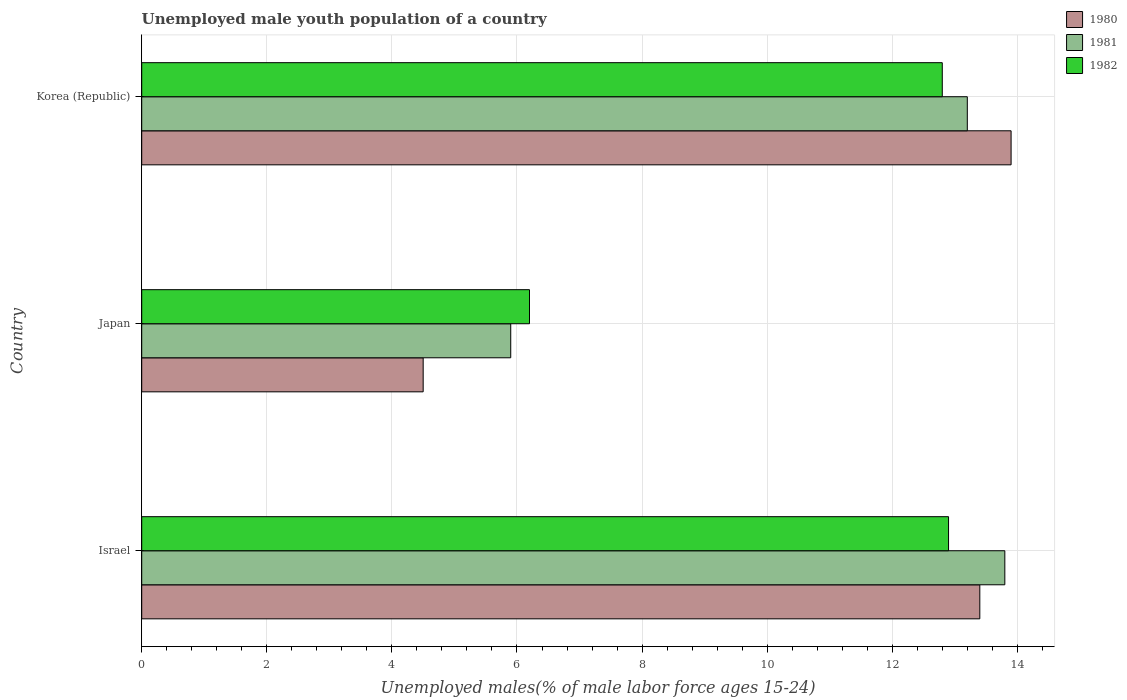Are the number of bars per tick equal to the number of legend labels?
Make the answer very short. Yes. How many bars are there on the 2nd tick from the top?
Your response must be concise. 3. How many bars are there on the 2nd tick from the bottom?
Provide a succinct answer. 3. What is the percentage of unemployed male youth population in 1982 in Japan?
Give a very brief answer. 6.2. Across all countries, what is the maximum percentage of unemployed male youth population in 1982?
Make the answer very short. 12.9. Across all countries, what is the minimum percentage of unemployed male youth population in 1982?
Give a very brief answer. 6.2. In which country was the percentage of unemployed male youth population in 1982 maximum?
Your answer should be very brief. Israel. What is the total percentage of unemployed male youth population in 1981 in the graph?
Your answer should be compact. 32.9. What is the difference between the percentage of unemployed male youth population in 1981 in Japan and that in Korea (Republic)?
Keep it short and to the point. -7.3. What is the difference between the percentage of unemployed male youth population in 1980 in Israel and the percentage of unemployed male youth population in 1982 in Japan?
Your response must be concise. 7.2. What is the average percentage of unemployed male youth population in 1981 per country?
Your response must be concise. 10.97. What is the difference between the percentage of unemployed male youth population in 1980 and percentage of unemployed male youth population in 1982 in Japan?
Keep it short and to the point. -1.7. What is the ratio of the percentage of unemployed male youth population in 1980 in Israel to that in Japan?
Give a very brief answer. 2.98. Is the difference between the percentage of unemployed male youth population in 1980 in Israel and Korea (Republic) greater than the difference between the percentage of unemployed male youth population in 1982 in Israel and Korea (Republic)?
Keep it short and to the point. No. What is the difference between the highest and the second highest percentage of unemployed male youth population in 1980?
Provide a short and direct response. 0.5. What is the difference between the highest and the lowest percentage of unemployed male youth population in 1980?
Offer a very short reply. 9.4. In how many countries, is the percentage of unemployed male youth population in 1982 greater than the average percentage of unemployed male youth population in 1982 taken over all countries?
Your response must be concise. 2. Is the sum of the percentage of unemployed male youth population in 1981 in Israel and Japan greater than the maximum percentage of unemployed male youth population in 1980 across all countries?
Provide a short and direct response. Yes. What does the 3rd bar from the bottom in Japan represents?
Provide a short and direct response. 1982. How many bars are there?
Offer a very short reply. 9. What is the difference between two consecutive major ticks on the X-axis?
Your response must be concise. 2. Are the values on the major ticks of X-axis written in scientific E-notation?
Offer a terse response. No. Does the graph contain any zero values?
Keep it short and to the point. No. How many legend labels are there?
Your answer should be very brief. 3. What is the title of the graph?
Ensure brevity in your answer.  Unemployed male youth population of a country. What is the label or title of the X-axis?
Your answer should be compact. Unemployed males(% of male labor force ages 15-24). What is the Unemployed males(% of male labor force ages 15-24) of 1980 in Israel?
Make the answer very short. 13.4. What is the Unemployed males(% of male labor force ages 15-24) of 1981 in Israel?
Give a very brief answer. 13.8. What is the Unemployed males(% of male labor force ages 15-24) in 1982 in Israel?
Your answer should be compact. 12.9. What is the Unemployed males(% of male labor force ages 15-24) of 1981 in Japan?
Provide a succinct answer. 5.9. What is the Unemployed males(% of male labor force ages 15-24) in 1982 in Japan?
Give a very brief answer. 6.2. What is the Unemployed males(% of male labor force ages 15-24) in 1980 in Korea (Republic)?
Your answer should be very brief. 13.9. What is the Unemployed males(% of male labor force ages 15-24) of 1981 in Korea (Republic)?
Give a very brief answer. 13.2. What is the Unemployed males(% of male labor force ages 15-24) in 1982 in Korea (Republic)?
Ensure brevity in your answer.  12.8. Across all countries, what is the maximum Unemployed males(% of male labor force ages 15-24) of 1980?
Give a very brief answer. 13.9. Across all countries, what is the maximum Unemployed males(% of male labor force ages 15-24) in 1981?
Your answer should be compact. 13.8. Across all countries, what is the maximum Unemployed males(% of male labor force ages 15-24) of 1982?
Provide a succinct answer. 12.9. Across all countries, what is the minimum Unemployed males(% of male labor force ages 15-24) in 1980?
Provide a succinct answer. 4.5. Across all countries, what is the minimum Unemployed males(% of male labor force ages 15-24) in 1981?
Provide a succinct answer. 5.9. Across all countries, what is the minimum Unemployed males(% of male labor force ages 15-24) in 1982?
Make the answer very short. 6.2. What is the total Unemployed males(% of male labor force ages 15-24) of 1980 in the graph?
Keep it short and to the point. 31.8. What is the total Unemployed males(% of male labor force ages 15-24) in 1981 in the graph?
Your answer should be compact. 32.9. What is the total Unemployed males(% of male labor force ages 15-24) of 1982 in the graph?
Provide a short and direct response. 31.9. What is the difference between the Unemployed males(% of male labor force ages 15-24) of 1980 in Israel and that in Japan?
Offer a very short reply. 8.9. What is the difference between the Unemployed males(% of male labor force ages 15-24) in 1981 in Japan and that in Korea (Republic)?
Ensure brevity in your answer.  -7.3. What is the difference between the Unemployed males(% of male labor force ages 15-24) of 1980 in Israel and the Unemployed males(% of male labor force ages 15-24) of 1982 in Japan?
Give a very brief answer. 7.2. What is the difference between the Unemployed males(% of male labor force ages 15-24) of 1981 in Israel and the Unemployed males(% of male labor force ages 15-24) of 1982 in Japan?
Keep it short and to the point. 7.6. What is the difference between the Unemployed males(% of male labor force ages 15-24) in 1980 in Japan and the Unemployed males(% of male labor force ages 15-24) in 1982 in Korea (Republic)?
Ensure brevity in your answer.  -8.3. What is the average Unemployed males(% of male labor force ages 15-24) in 1980 per country?
Ensure brevity in your answer.  10.6. What is the average Unemployed males(% of male labor force ages 15-24) of 1981 per country?
Offer a very short reply. 10.97. What is the average Unemployed males(% of male labor force ages 15-24) of 1982 per country?
Provide a succinct answer. 10.63. What is the difference between the Unemployed males(% of male labor force ages 15-24) of 1980 and Unemployed males(% of male labor force ages 15-24) of 1981 in Israel?
Make the answer very short. -0.4. What is the difference between the Unemployed males(% of male labor force ages 15-24) in 1981 and Unemployed males(% of male labor force ages 15-24) in 1982 in Israel?
Offer a terse response. 0.9. What is the difference between the Unemployed males(% of male labor force ages 15-24) in 1980 and Unemployed males(% of male labor force ages 15-24) in 1982 in Japan?
Give a very brief answer. -1.7. What is the difference between the Unemployed males(% of male labor force ages 15-24) of 1981 and Unemployed males(% of male labor force ages 15-24) of 1982 in Japan?
Your answer should be very brief. -0.3. What is the ratio of the Unemployed males(% of male labor force ages 15-24) of 1980 in Israel to that in Japan?
Provide a succinct answer. 2.98. What is the ratio of the Unemployed males(% of male labor force ages 15-24) in 1981 in Israel to that in Japan?
Provide a short and direct response. 2.34. What is the ratio of the Unemployed males(% of male labor force ages 15-24) of 1982 in Israel to that in Japan?
Provide a short and direct response. 2.08. What is the ratio of the Unemployed males(% of male labor force ages 15-24) of 1980 in Israel to that in Korea (Republic)?
Offer a terse response. 0.96. What is the ratio of the Unemployed males(% of male labor force ages 15-24) of 1981 in Israel to that in Korea (Republic)?
Your response must be concise. 1.05. What is the ratio of the Unemployed males(% of male labor force ages 15-24) in 1982 in Israel to that in Korea (Republic)?
Keep it short and to the point. 1.01. What is the ratio of the Unemployed males(% of male labor force ages 15-24) in 1980 in Japan to that in Korea (Republic)?
Ensure brevity in your answer.  0.32. What is the ratio of the Unemployed males(% of male labor force ages 15-24) in 1981 in Japan to that in Korea (Republic)?
Offer a very short reply. 0.45. What is the ratio of the Unemployed males(% of male labor force ages 15-24) of 1982 in Japan to that in Korea (Republic)?
Offer a terse response. 0.48. What is the difference between the highest and the second highest Unemployed males(% of male labor force ages 15-24) in 1980?
Your answer should be very brief. 0.5. What is the difference between the highest and the lowest Unemployed males(% of male labor force ages 15-24) of 1980?
Your response must be concise. 9.4. What is the difference between the highest and the lowest Unemployed males(% of male labor force ages 15-24) of 1982?
Make the answer very short. 6.7. 